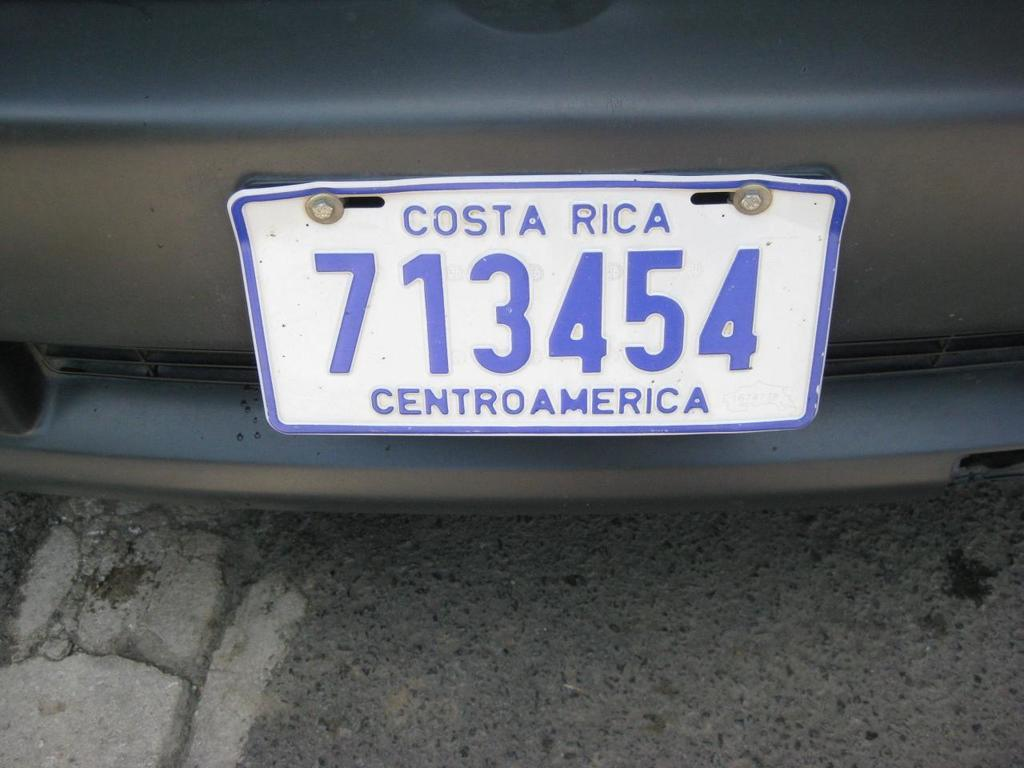<image>
Present a compact description of the photo's key features. A blue and white Costa Rica License plate from central america. 